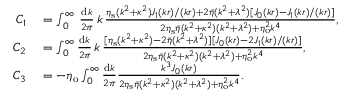<formula> <loc_0><loc_0><loc_500><loc_500>\begin{array} { r l } { C _ { 1 } } & = \int _ { 0 } ^ { \infty } \, \frac { d k } { 2 \pi } \, k \, \frac { \eta _ { s } ( k ^ { 2 } + \kappa ^ { 2 } ) J _ { 1 } ( k r ) / ( k r ) + 2 \bar { \eta } ( k ^ { 2 } + \lambda ^ { 2 } ) [ J _ { 0 } ( k r ) - J _ { 1 } ( k r ) / ( k r ) ] } { 2 \eta _ { s } \bar { \eta } ( k ^ { 2 } + \kappa ^ { 2 } ) ( k ^ { 2 } + \lambda ^ { 2 } ) + \eta _ { o } ^ { 2 } k ^ { 4 } } , } \\ { C _ { 2 } } & = \int _ { 0 } ^ { \infty } \frac { d k } { 2 \pi } \, k \, \frac { [ \eta _ { s } ( k ^ { 2 } + \kappa ^ { 2 } ) - 2 \bar { \eta } ( k ^ { 2 } + \lambda ^ { 2 } ) ] [ J _ { 0 } ( k r ) - 2 J _ { 1 } ( k r ) / ( k r ) ] } { 2 \eta _ { s } \bar { \eta } ( k ^ { 2 } + \kappa ^ { 2 } ) ( k ^ { 2 } + \lambda ^ { 2 } ) + \eta _ { o } ^ { 2 } k ^ { 4 } } , } \\ { C _ { 3 } } & = - \eta _ { o } \int _ { 0 } ^ { \infty } \frac { d k } { 2 \pi } \frac { k ^ { 3 } J _ { 0 } ( k r ) } { 2 \eta _ { s } \bar { \eta } ( k ^ { 2 } + \kappa ^ { 2 } ) ( k ^ { 2 } + \lambda ^ { 2 } ) + \eta _ { o } ^ { 2 } k ^ { 4 } } . } \end{array}</formula> 